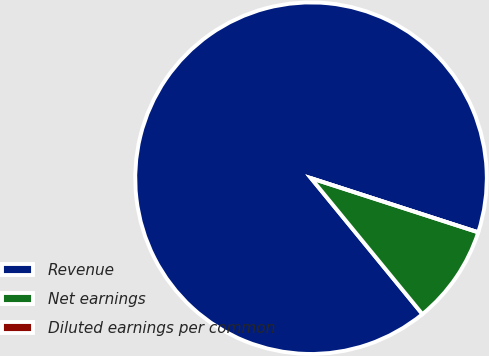Convert chart. <chart><loc_0><loc_0><loc_500><loc_500><pie_chart><fcel>Revenue<fcel>Net earnings<fcel>Diluted earnings per common<nl><fcel>90.91%<fcel>9.09%<fcel>0.0%<nl></chart> 